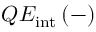Convert formula to latex. <formula><loc_0><loc_0><loc_500><loc_500>Q E _ { i n t } \, ( - )</formula> 